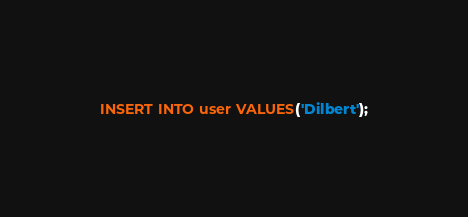<code> <loc_0><loc_0><loc_500><loc_500><_SQL_>INSERT INTO user VALUES('Dilbert');</code> 